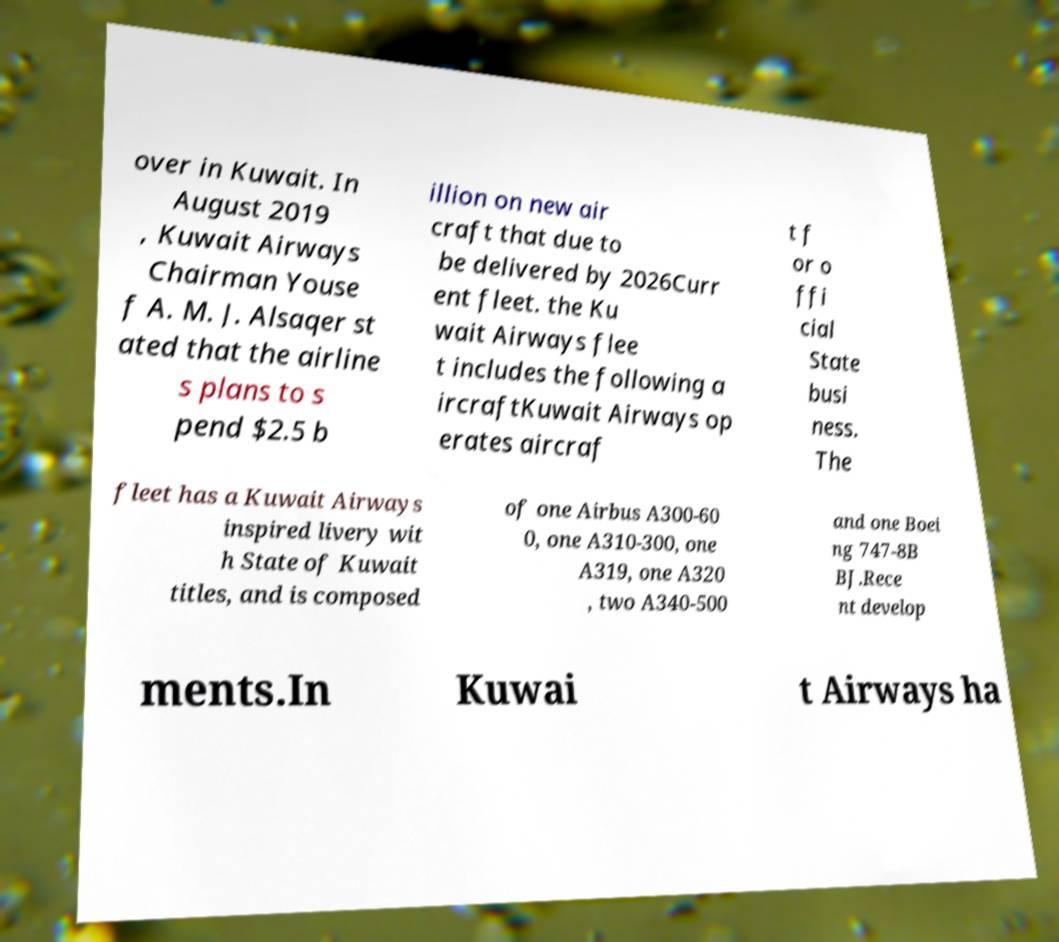Please read and relay the text visible in this image. What does it say? over in Kuwait. In August 2019 , Kuwait Airways Chairman Youse f A. M. J. Alsaqer st ated that the airline s plans to s pend $2.5 b illion on new air craft that due to be delivered by 2026Curr ent fleet. the Ku wait Airways flee t includes the following a ircraftKuwait Airways op erates aircraf t f or o ffi cial State busi ness. The fleet has a Kuwait Airways inspired livery wit h State of Kuwait titles, and is composed of one Airbus A300-60 0, one A310-300, one A319, one A320 , two A340-500 and one Boei ng 747-8B BJ.Rece nt develop ments.In Kuwai t Airways ha 